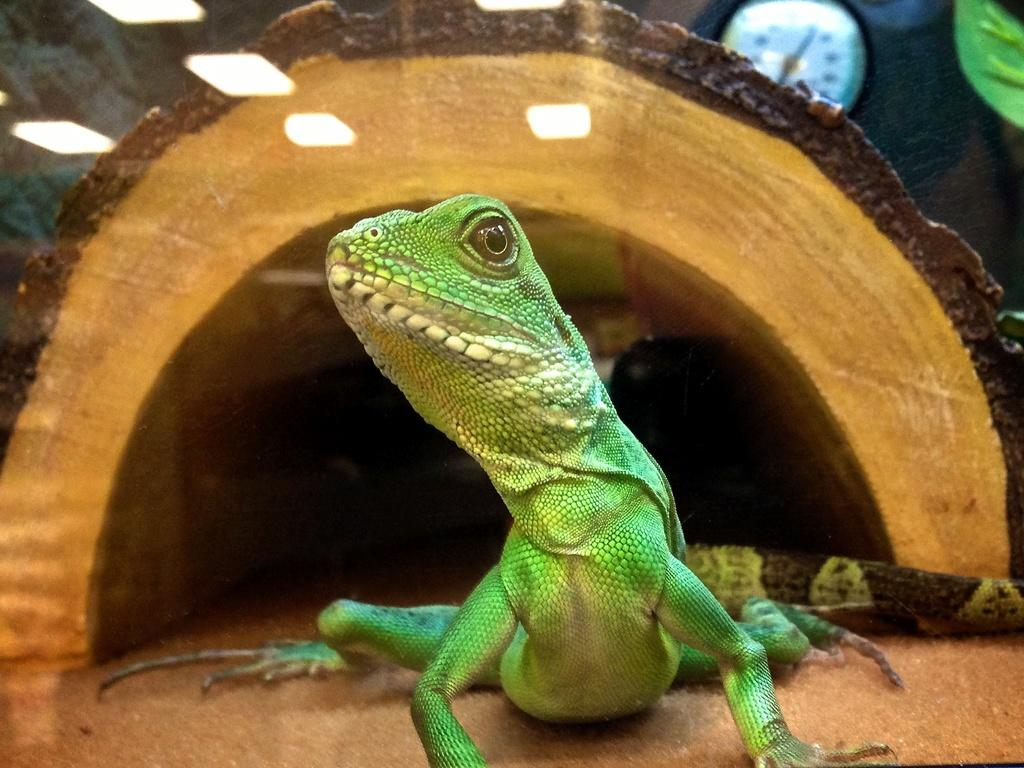What type of animal is in the image? There is a reptile in the image. What is the reptile contained within? The reptile is in a cage in the image. What object can be seen in the background of the image? There is a clock in the background of the image. What type of locket is the reptile wearing in the image? There is no locket present in the image; the reptile is in a cage and does not have any accessories. 